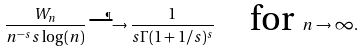<formula> <loc_0><loc_0><loc_500><loc_500>\frac { W _ { n } } { n ^ { - s } s \log ( n ) } \overset { \P } { \longrightarrow } \frac { 1 } { s \Gamma ( 1 + 1 / s ) ^ { s } } \quad \text {for } n \to \infty .</formula> 